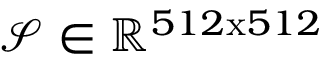<formula> <loc_0><loc_0><loc_500><loc_500>\mathcal { S } \in \mathbb { R } ^ { 5 1 2 x 5 1 2 }</formula> 